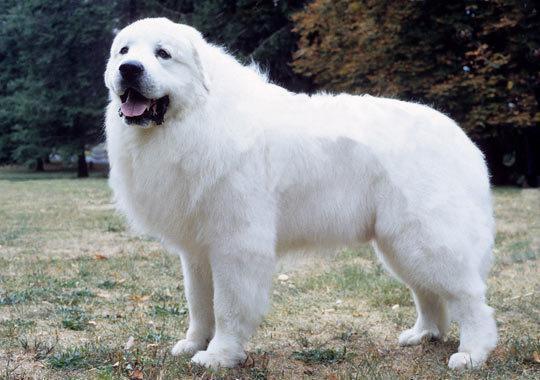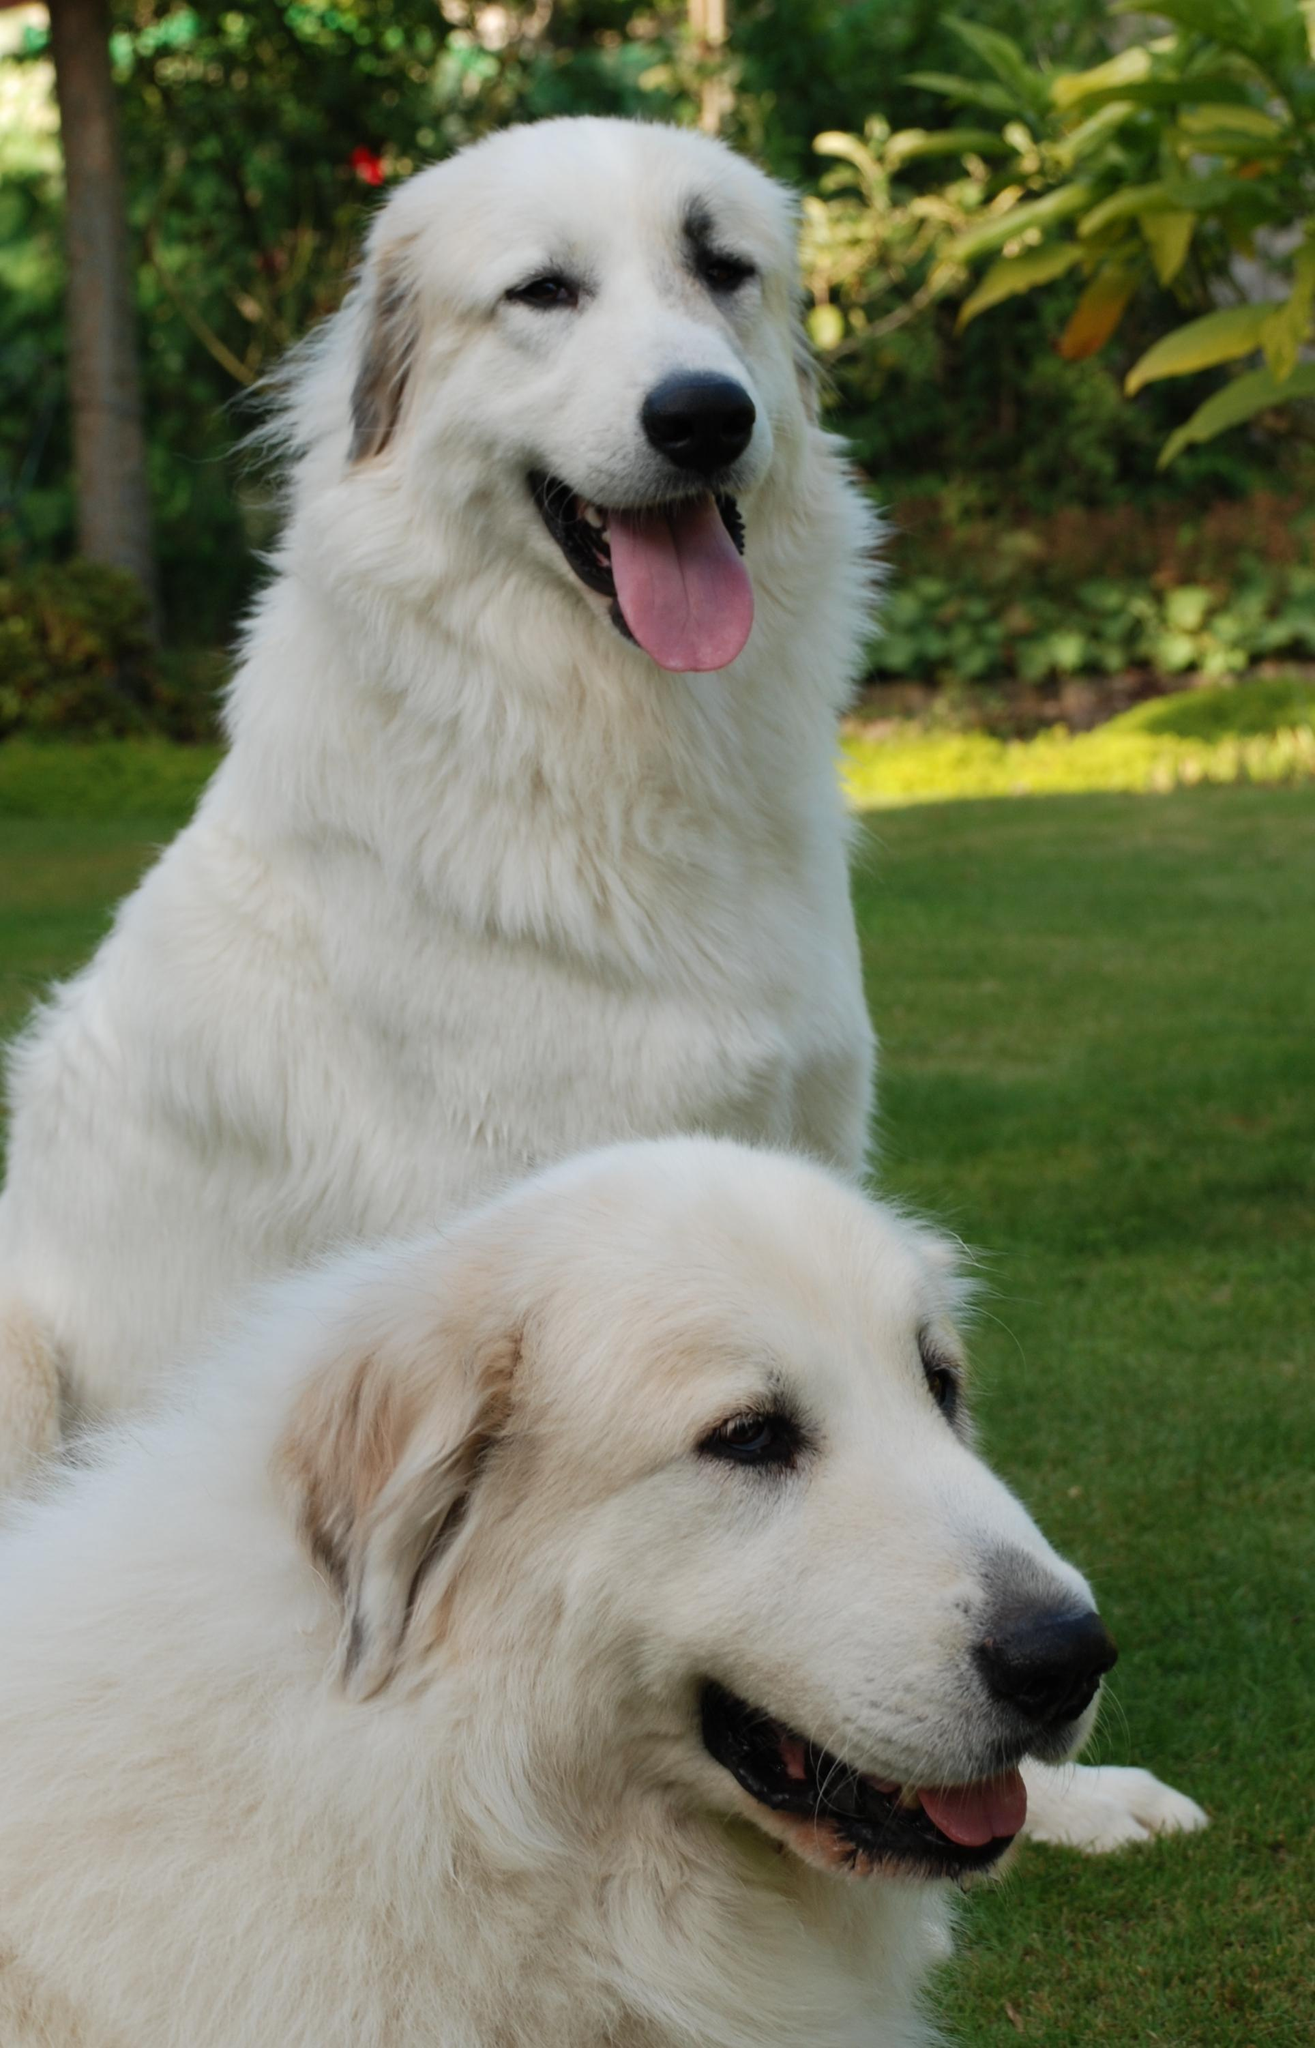The first image is the image on the left, the second image is the image on the right. For the images shown, is this caption "Left image shows a dog standing in profile with body turned leftward." true? Answer yes or no. Yes. The first image is the image on the left, the second image is the image on the right. Considering the images on both sides, is "At least one of the dogs has its tongue sticking out." valid? Answer yes or no. Yes. The first image is the image on the left, the second image is the image on the right. Analyze the images presented: Is the assertion "There are two dogs" valid? Answer yes or no. No. 